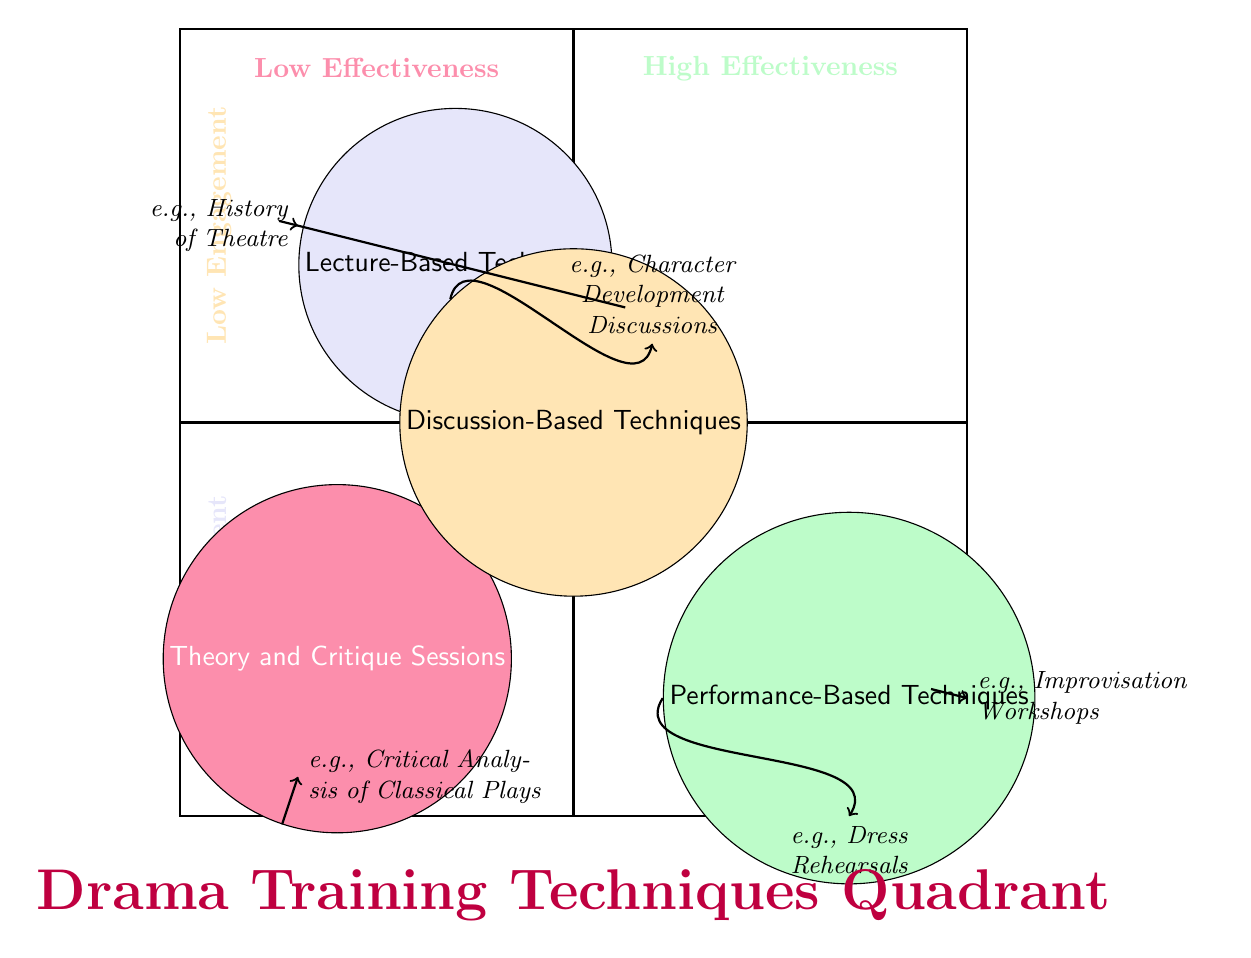What is the placement of Theory and Critique Sessions in the quadrant? The Theory and Critique Sessions are located in the bottom left quadrant where both engagement and effectiveness are low. This placement can be identified by looking at the coordinates set for this node in the diagram.
Answer: Bottom left How many techniques are categorized as having High Engagement? There are two techniques located in the High Engagement area of the diagram: Practical Workshops and Performance-Based Techniques. The count can be easily determined by observing the corresponding locations in the upper half of the quadrant.
Answer: 2 What is the effectiveness level of Practical Workshops? Practical Workshops are located in the High Effectiveness quadrant, which is indicated by their placement in the top right section of the chart. This can be determined by looking at the quadrant labels.
Answer: High Which technique has the lowest effectiveness? Theory and Critique Sessions have the lowest effectiveness level as they are positioned in the bottom left quadrant, which indicates low engagement and low effectiveness.
Answer: Theory and Critique Sessions Do any techniques fall into the Low Engagement and Medium Effectiveness zone? No, there are no techniques that occupy the Low Engagement and Medium Effectiveness quadrant. This can be inferred from examining the chart where all positioned techniques are classified in either High or Low engagement areas.
Answer: No What examples are associated with Discussion-Based Techniques? The examples listed under Discussion-Based Techniques include Character Development Discussions and Group Script Read-Throughs. These can be found in the text associated with the node in the middle of the quadrant.
Answer: Character Development Discussions, Group Script Read-Throughs Which quadrant contains Lecture-Based Techniques? Lecture-Based Techniques are located in the Low Effectiveness and High Engagement quadrant, specifically just below the top section on the left side. The quadrant can be identified by tracing the positioning of this node.
Answer: Low Effectiveness, High Engagement What is the primary focus of Practical Workshops? The primary focus of Practical Workshops is hands-on learning experiences involving active participation. This information is explicitly mentioned in the description associated with this technique in the diagram.
Answer: Hands-on learning experiences 